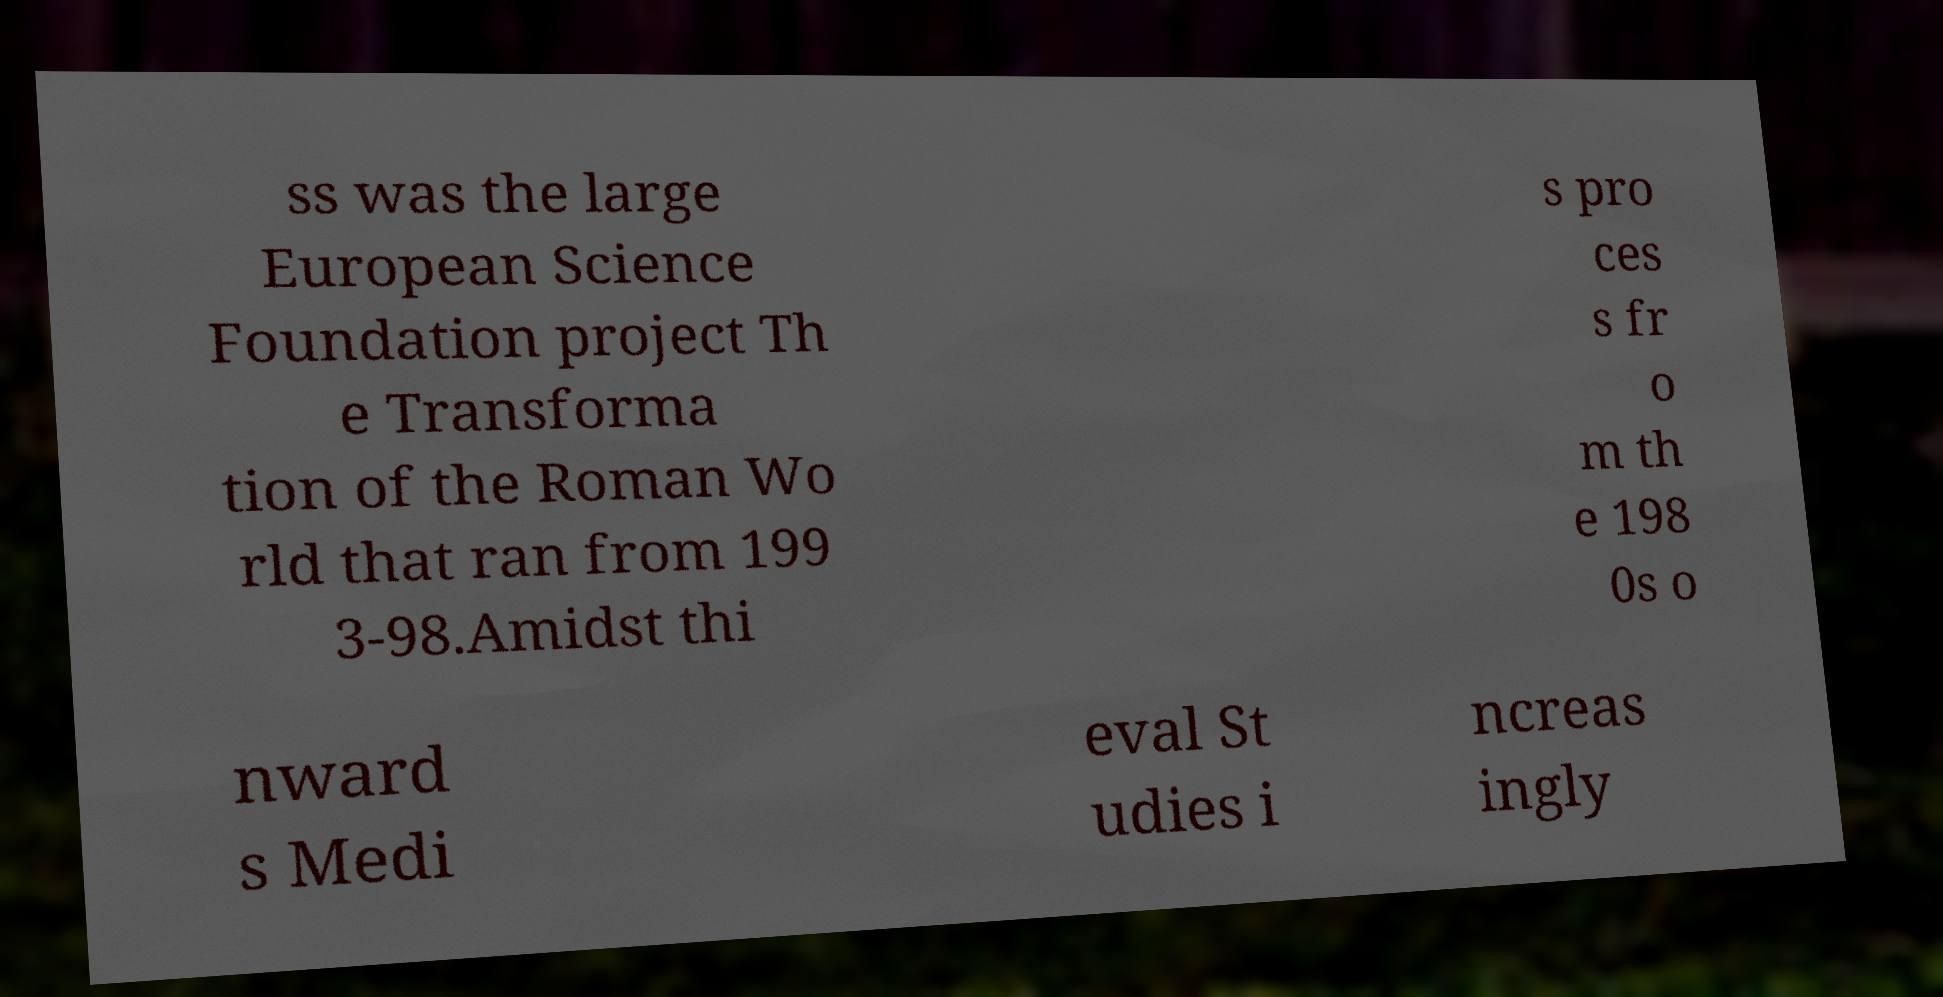Could you assist in decoding the text presented in this image and type it out clearly? ss was the large European Science Foundation project Th e Transforma tion of the Roman Wo rld that ran from 199 3-98.Amidst thi s pro ces s fr o m th e 198 0s o nward s Medi eval St udies i ncreas ingly 